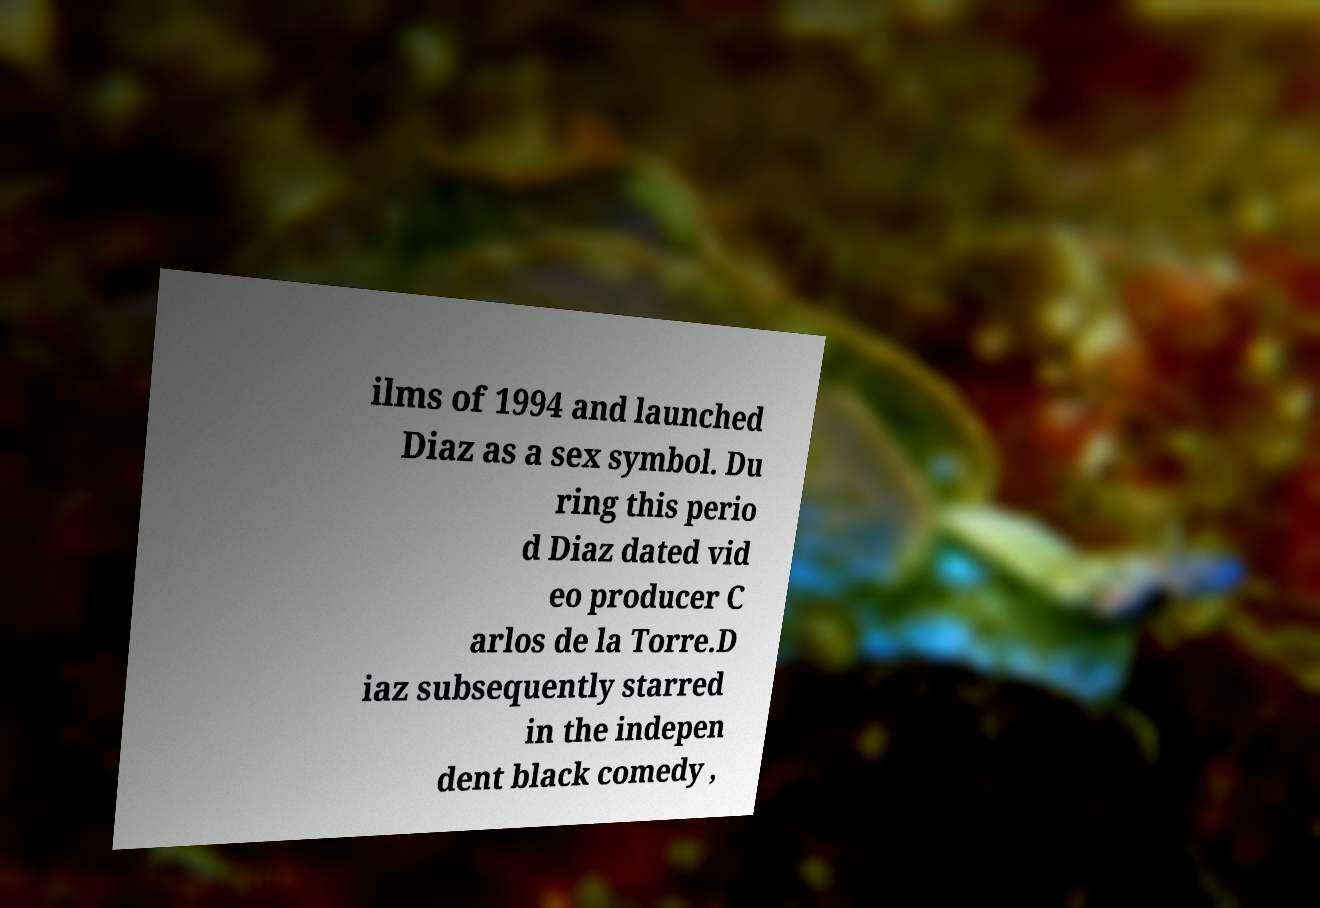Could you assist in decoding the text presented in this image and type it out clearly? ilms of 1994 and launched Diaz as a sex symbol. Du ring this perio d Diaz dated vid eo producer C arlos de la Torre.D iaz subsequently starred in the indepen dent black comedy , 